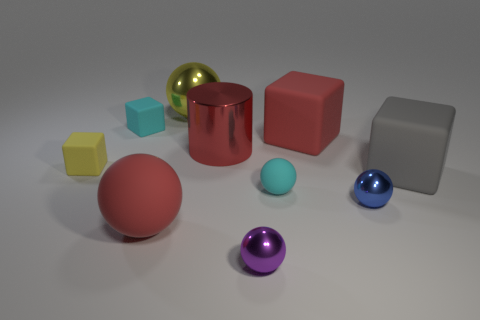Are the large thing that is behind the cyan cube and the tiny cyan object that is on the right side of the big yellow ball made of the same material?
Your response must be concise. No. How big is the red matte thing to the left of the cyan ball left of the big gray cube?
Provide a succinct answer. Large. Is there a small shiny block that has the same color as the shiny cylinder?
Your response must be concise. No. Do the big sphere in front of the small cyan matte cube and the large cube that is to the left of the gray object have the same color?
Your answer should be compact. Yes. What shape is the tiny purple object?
Offer a very short reply. Sphere. How many red objects are left of the tiny cyan ball?
Your response must be concise. 2. How many tiny red cylinders have the same material as the tiny yellow cube?
Offer a terse response. 0. Is the material of the tiny sphere that is right of the small matte ball the same as the cylinder?
Make the answer very short. Yes. Is there a matte ball?
Keep it short and to the point. Yes. What size is the shiny object that is both behind the large gray matte object and in front of the yellow sphere?
Offer a very short reply. Large. 